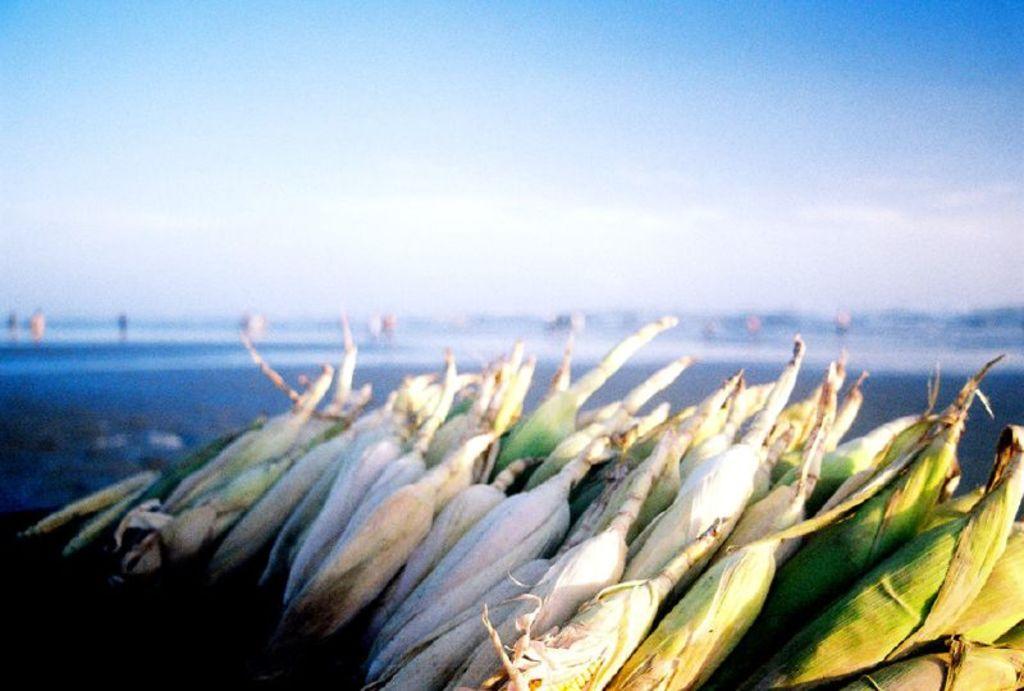How would you summarize this image in a sentence or two? In this image, we can see there are corns arranged on a surface. In the background, there are clouds in the blue sky. And the background is blurred. 